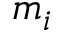<formula> <loc_0><loc_0><loc_500><loc_500>m _ { i }</formula> 